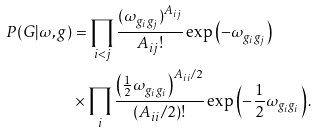<formula> <loc_0><loc_0><loc_500><loc_500>P ( G | \omega , g ) & = \prod _ { i < j } \frac { ( \omega _ { g _ { i } g _ { j } } ) ^ { A _ { i j } } } { A _ { i j } ! } \exp \left ( - \omega _ { g _ { i } g _ { j } } \right ) \\ & \times \prod _ { i } \frac { \left ( \frac { 1 } { 2 } \omega _ { g _ { i } g _ { i } } \right ) ^ { A _ { i i } / 2 } } { ( A _ { i i } / 2 ) ! } \exp \left ( - \frac { 1 } { 2 } \omega _ { g _ { i } g _ { i } } \right ) .</formula> 